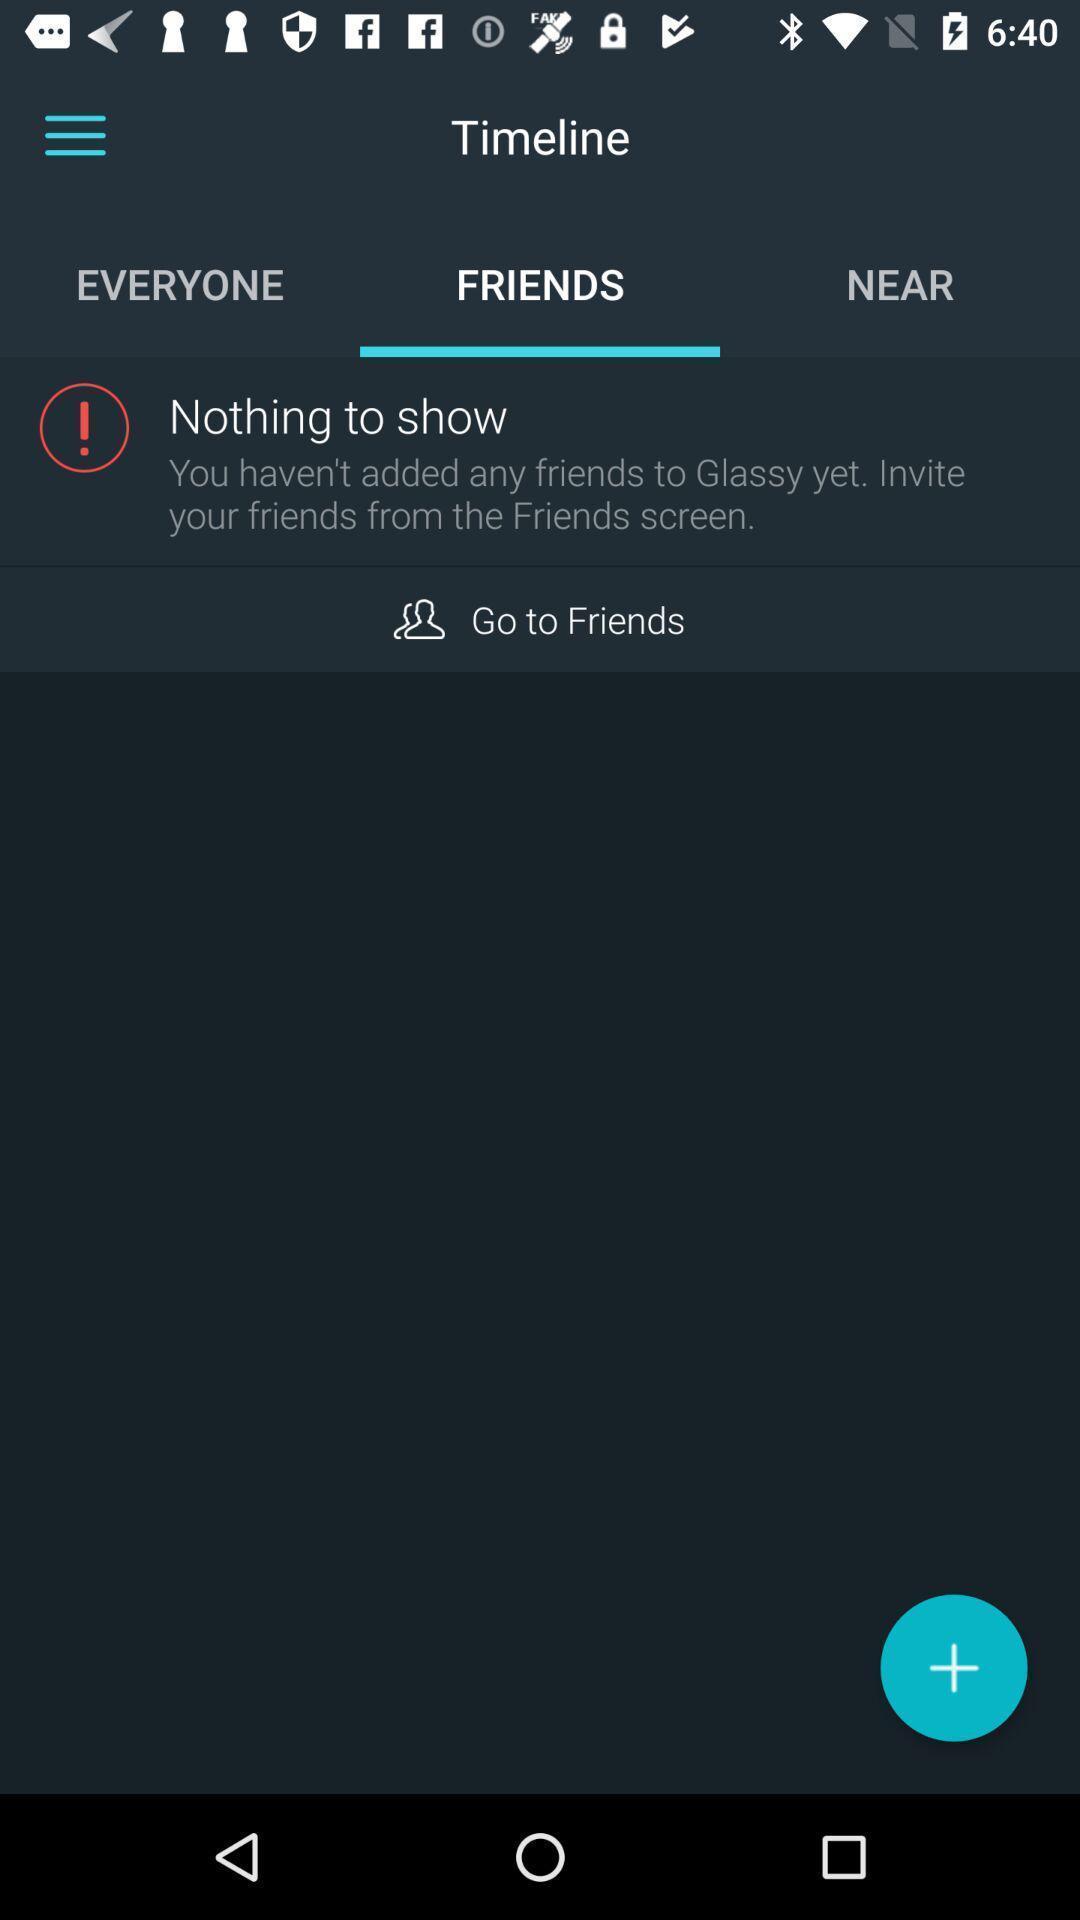Give me a narrative description of this picture. Screen shows time line of friends. 